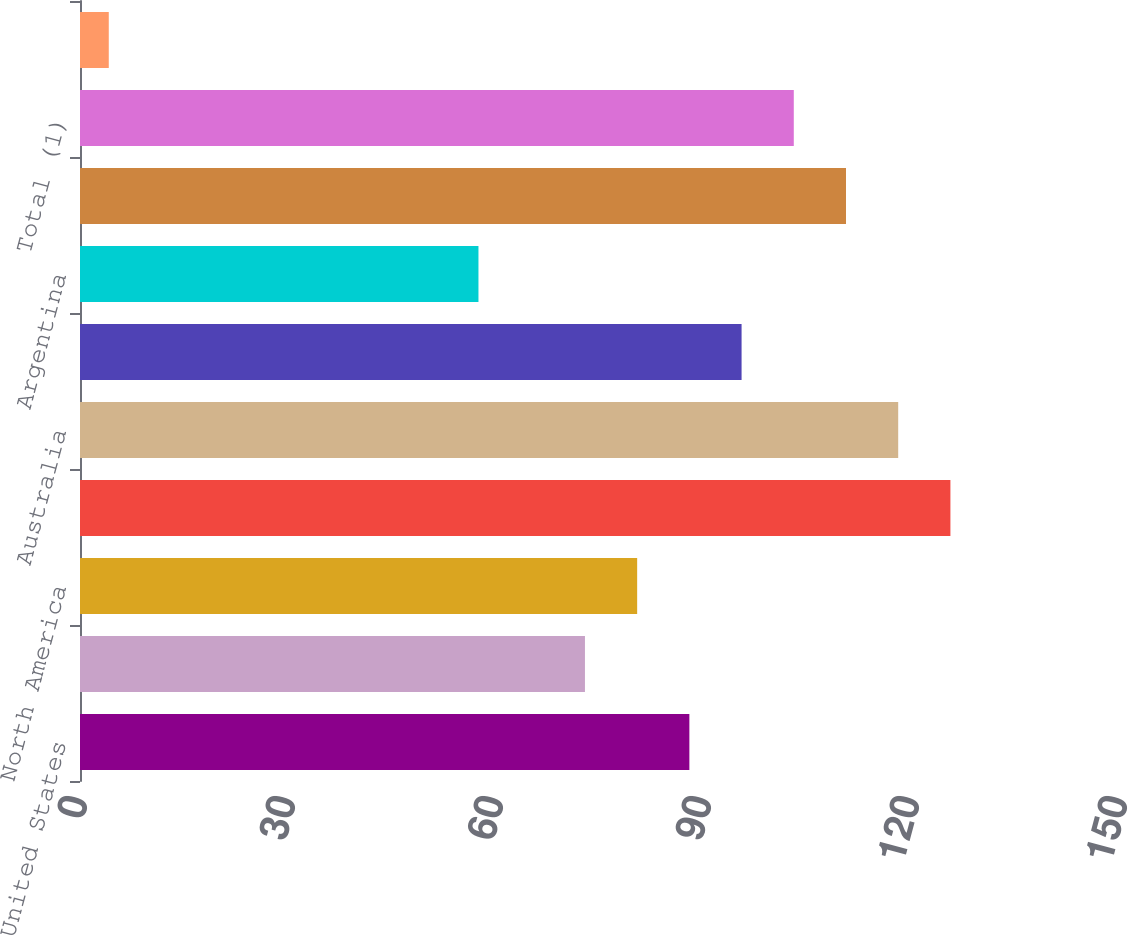Convert chart to OTSL. <chart><loc_0><loc_0><loc_500><loc_500><bar_chart><fcel>United States<fcel>Canada<fcel>North America<fcel>Egypt<fcel>Australia<fcel>North Sea<fcel>Argentina<fcel>International<fcel>Total (1)<fcel>Total (2)<nl><fcel>87.89<fcel>72.83<fcel>80.36<fcel>125.54<fcel>118.01<fcel>95.42<fcel>57.47<fcel>110.48<fcel>102.95<fcel>4.15<nl></chart> 